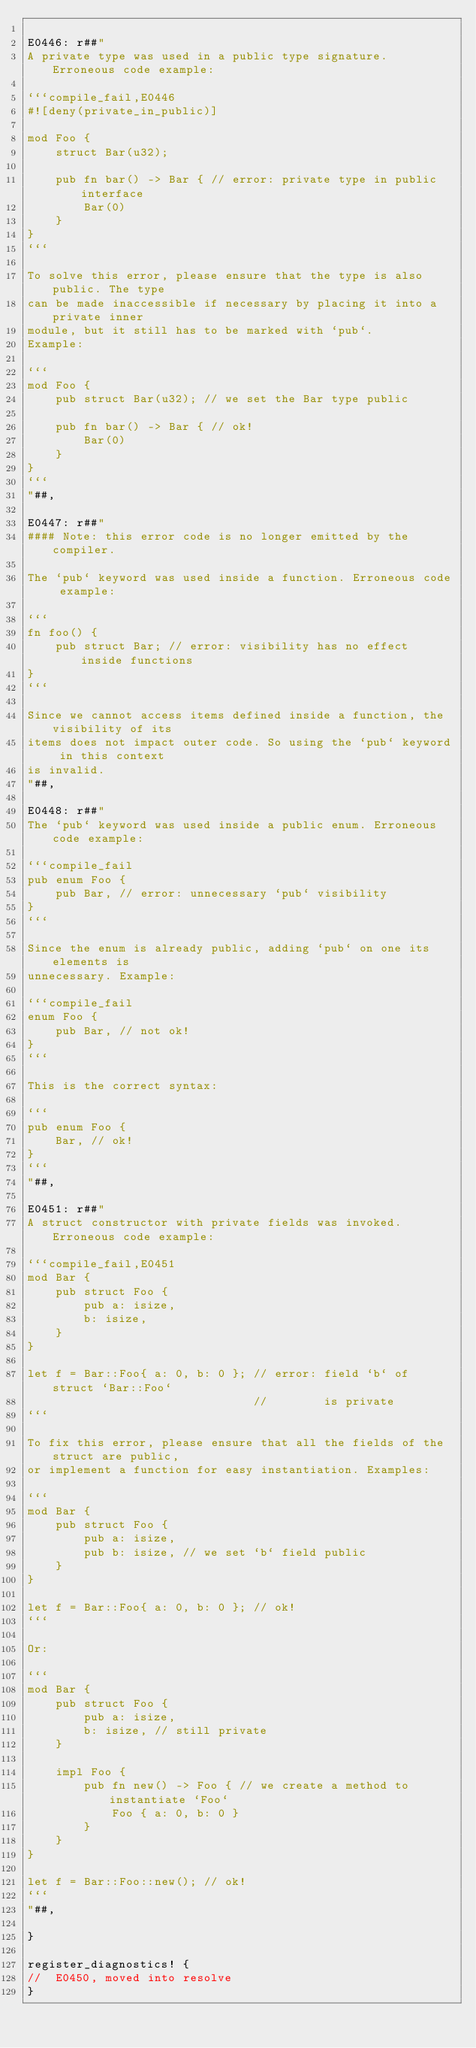Convert code to text. <code><loc_0><loc_0><loc_500><loc_500><_Rust_>
E0446: r##"
A private type was used in a public type signature. Erroneous code example:

```compile_fail,E0446
#![deny(private_in_public)]

mod Foo {
    struct Bar(u32);

    pub fn bar() -> Bar { // error: private type in public interface
        Bar(0)
    }
}
```

To solve this error, please ensure that the type is also public. The type
can be made inaccessible if necessary by placing it into a private inner
module, but it still has to be marked with `pub`.
Example:

```
mod Foo {
    pub struct Bar(u32); // we set the Bar type public

    pub fn bar() -> Bar { // ok!
        Bar(0)
    }
}
```
"##,

E0447: r##"
#### Note: this error code is no longer emitted by the compiler.

The `pub` keyword was used inside a function. Erroneous code example:

```
fn foo() {
    pub struct Bar; // error: visibility has no effect inside functions
}
```

Since we cannot access items defined inside a function, the visibility of its
items does not impact outer code. So using the `pub` keyword in this context
is invalid.
"##,

E0448: r##"
The `pub` keyword was used inside a public enum. Erroneous code example:

```compile_fail
pub enum Foo {
    pub Bar, // error: unnecessary `pub` visibility
}
```

Since the enum is already public, adding `pub` on one its elements is
unnecessary. Example:

```compile_fail
enum Foo {
    pub Bar, // not ok!
}
```

This is the correct syntax:

```
pub enum Foo {
    Bar, // ok!
}
```
"##,

E0451: r##"
A struct constructor with private fields was invoked. Erroneous code example:

```compile_fail,E0451
mod Bar {
    pub struct Foo {
        pub a: isize,
        b: isize,
    }
}

let f = Bar::Foo{ a: 0, b: 0 }; // error: field `b` of struct `Bar::Foo`
                                //        is private
```

To fix this error, please ensure that all the fields of the struct are public,
or implement a function for easy instantiation. Examples:

```
mod Bar {
    pub struct Foo {
        pub a: isize,
        pub b: isize, // we set `b` field public
    }
}

let f = Bar::Foo{ a: 0, b: 0 }; // ok!
```

Or:

```
mod Bar {
    pub struct Foo {
        pub a: isize,
        b: isize, // still private
    }

    impl Foo {
        pub fn new() -> Foo { // we create a method to instantiate `Foo`
            Foo { a: 0, b: 0 }
        }
    }
}

let f = Bar::Foo::new(); // ok!
```
"##,

}

register_diagnostics! {
//  E0450, moved into resolve
}
</code> 